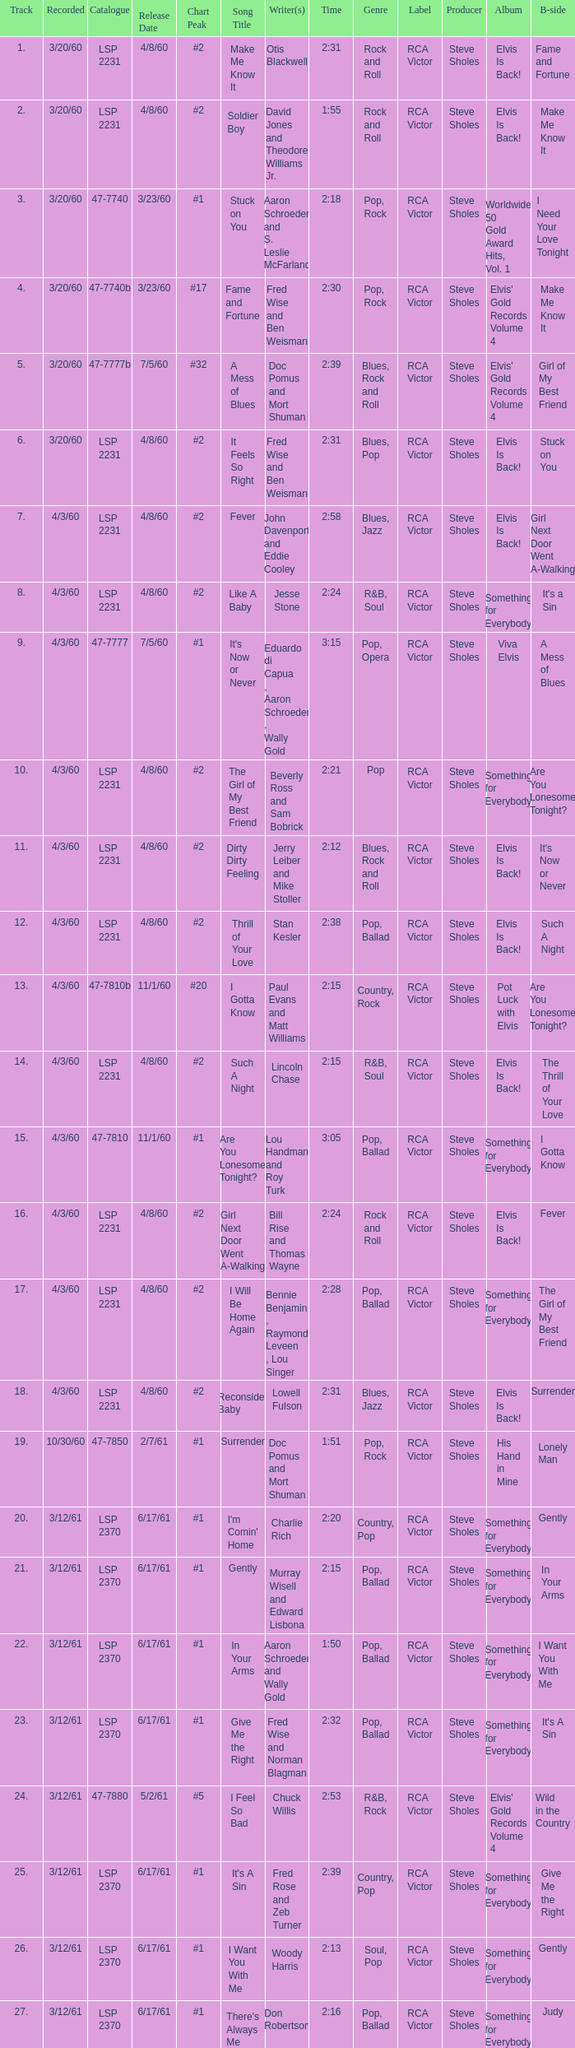What is the time of songs that have the writer Aaron Schroeder and Wally Gold? 1:50. I'm looking to parse the entire table for insights. Could you assist me with that? {'header': ['Track', 'Recorded', 'Catalogue', 'Release Date', 'Chart Peak', 'Song Title', 'Writer(s)', 'Time', 'Genre', 'Label', 'Producer', 'Album', 'B-side'], 'rows': [['1.', '3/20/60', 'LSP 2231', '4/8/60', '#2', 'Make Me Know It', 'Otis Blackwell', '2:31', 'Rock and Roll', 'RCA Victor', 'Steve Sholes', 'Elvis Is Back!', 'Fame and Fortune'], ['2.', '3/20/60', 'LSP 2231', '4/8/60', '#2', 'Soldier Boy', 'David Jones and Theodore Williams Jr.', '1:55', 'Rock and Roll', 'RCA Victor', 'Steve Sholes', 'Elvis Is Back!', 'Make Me Know It'], ['3.', '3/20/60', '47-7740', '3/23/60', '#1', 'Stuck on You', 'Aaron Schroeder and S. Leslie McFarland', '2:18', 'Pop, Rock', 'RCA Victor', 'Steve Sholes', 'Worldwide 50 Gold Award Hits, Vol. 1', 'I Need Your Love Tonight'], ['4.', '3/20/60', '47-7740b', '3/23/60', '#17', 'Fame and Fortune', 'Fred Wise and Ben Weisman', '2:30', 'Pop, Rock', 'RCA Victor', 'Steve Sholes', "Elvis' Gold Records Volume 4", 'Make Me Know It'], ['5.', '3/20/60', '47-7777b', '7/5/60', '#32', 'A Mess of Blues', 'Doc Pomus and Mort Shuman', '2:39', 'Blues, Rock and Roll', 'RCA Victor', 'Steve Sholes', "Elvis' Gold Records Volume 4", 'Girl of My Best Friend'], ['6.', '3/20/60', 'LSP 2231', '4/8/60', '#2', 'It Feels So Right', 'Fred Wise and Ben Weisman', '2:31', 'Blues, Pop', 'RCA Victor', 'Steve Sholes', 'Elvis Is Back!', 'Stuck on You'], ['7.', '4/3/60', 'LSP 2231', '4/8/60', '#2', 'Fever', 'John Davenport and Eddie Cooley', '2:58', 'Blues, Jazz', 'RCA Victor', 'Steve Sholes', 'Elvis Is Back!', 'Girl Next Door Went A-Walking'], ['8.', '4/3/60', 'LSP 2231', '4/8/60', '#2', 'Like A Baby', 'Jesse Stone', '2:24', 'R&B, Soul', 'RCA Victor', 'Steve Sholes', 'Something for Everybody', "It's a Sin"], ['9.', '4/3/60', '47-7777', '7/5/60', '#1', "It's Now or Never", 'Eduardo di Capua , Aaron Schroeder , Wally Gold', '3:15', 'Pop, Opera', 'RCA Victor', 'Steve Sholes', 'Viva Elvis', 'A Mess of Blues'], ['10.', '4/3/60', 'LSP 2231', '4/8/60', '#2', 'The Girl of My Best Friend', 'Beverly Ross and Sam Bobrick', '2:21', 'Pop', 'RCA Victor', 'Steve Sholes', 'Something for Everybody', 'Are You Lonesome Tonight?'], ['11.', '4/3/60', 'LSP 2231', '4/8/60', '#2', 'Dirty Dirty Feeling', 'Jerry Leiber and Mike Stoller', '2:12', 'Blues, Rock and Roll', 'RCA Victor', 'Steve Sholes', 'Elvis Is Back!', "It's Now or Never"], ['12.', '4/3/60', 'LSP 2231', '4/8/60', '#2', 'Thrill of Your Love', 'Stan Kesler', '2:38', 'Pop, Ballad', 'RCA Victor', 'Steve Sholes', 'Elvis Is Back!', 'Such A Night'], ['13.', '4/3/60', '47-7810b', '11/1/60', '#20', 'I Gotta Know', 'Paul Evans and Matt Williams', '2:15', 'Country, Rock', 'RCA Victor', 'Steve Sholes', 'Pot Luck with Elvis', 'Are You Lonesome Tonight?'], ['14.', '4/3/60', 'LSP 2231', '4/8/60', '#2', 'Such A Night', 'Lincoln Chase', '2:15', 'R&B, Soul', 'RCA Victor', 'Steve Sholes', 'Elvis Is Back!', 'The Thrill of Your Love'], ['15.', '4/3/60', '47-7810', '11/1/60', '#1', 'Are You Lonesome Tonight?', 'Lou Handman and Roy Turk', '3:05', 'Pop, Ballad', 'RCA Victor', 'Steve Sholes', 'Something for Everybody', 'I Gotta Know'], ['16.', '4/3/60', 'LSP 2231', '4/8/60', '#2', 'Girl Next Door Went A-Walking', 'Bill Rise and Thomas Wayne', '2:24', 'Rock and Roll', 'RCA Victor', 'Steve Sholes', 'Elvis Is Back!', 'Fever'], ['17.', '4/3/60', 'LSP 2231', '4/8/60', '#2', 'I Will Be Home Again', 'Bennie Benjamin , Raymond Leveen , Lou Singer', '2:28', 'Pop, Ballad', 'RCA Victor', 'Steve Sholes', 'Something for Everybody', 'The Girl of My Best Friend'], ['18.', '4/3/60', 'LSP 2231', '4/8/60', '#2', 'Reconsider Baby', 'Lowell Fulson', '2:31', 'Blues, Jazz', 'RCA Victor', 'Steve Sholes', 'Elvis Is Back!', 'Surrender'], ['19.', '10/30/60', '47-7850', '2/7/61', '#1', 'Surrender', 'Doc Pomus and Mort Shuman', '1:51', 'Pop, Rock', 'RCA Victor', 'Steve Sholes', 'His Hand in Mine', 'Lonely Man'], ['20.', '3/12/61', 'LSP 2370', '6/17/61', '#1', "I'm Comin' Home", 'Charlie Rich', '2:20', 'Country, Pop', 'RCA Victor', 'Steve Sholes', 'Something for Everybody', 'Gently'], ['21.', '3/12/61', 'LSP 2370', '6/17/61', '#1', 'Gently', 'Murray Wisell and Edward Lisbona', '2:15', 'Pop, Ballad', 'RCA Victor', 'Steve Sholes', 'Something for Everybody', 'In Your Arms'], ['22.', '3/12/61', 'LSP 2370', '6/17/61', '#1', 'In Your Arms', 'Aaron Schroeder and Wally Gold', '1:50', 'Pop, Ballad', 'RCA Victor', 'Steve Sholes', 'Something for Everybody', 'I Want You With Me'], ['23.', '3/12/61', 'LSP 2370', '6/17/61', '#1', 'Give Me the Right', 'Fred Wise and Norman Blagman', '2:32', 'Pop, Ballad', 'RCA Victor', 'Steve Sholes', 'Something for Everybody', "It's A Sin"], ['24.', '3/12/61', '47-7880', '5/2/61', '#5', 'I Feel So Bad', 'Chuck Willis', '2:53', 'R&B, Rock', 'RCA Victor', 'Steve Sholes', "Elvis' Gold Records Volume 4", 'Wild in the Country'], ['25.', '3/12/61', 'LSP 2370', '6/17/61', '#1', "It's A Sin", 'Fred Rose and Zeb Turner', '2:39', 'Country, Pop', 'RCA Victor', 'Steve Sholes', 'Something for Everybody', 'Give Me the Right'], ['26.', '3/12/61', 'LSP 2370', '6/17/61', '#1', 'I Want You With Me', 'Woody Harris', '2:13', 'Soul, Pop', 'RCA Victor', 'Steve Sholes', 'Something for Everybody', 'Gently'], ['27.', '3/12/61', 'LSP 2370', '6/17/61', '#1', "There's Always Me", 'Don Robertson', '2:16', 'Pop, Ballad', 'RCA Victor', 'Steve Sholes', 'Something for Everybody', 'Judy']]} 